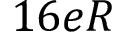<formula> <loc_0><loc_0><loc_500><loc_500>1 6 e R</formula> 